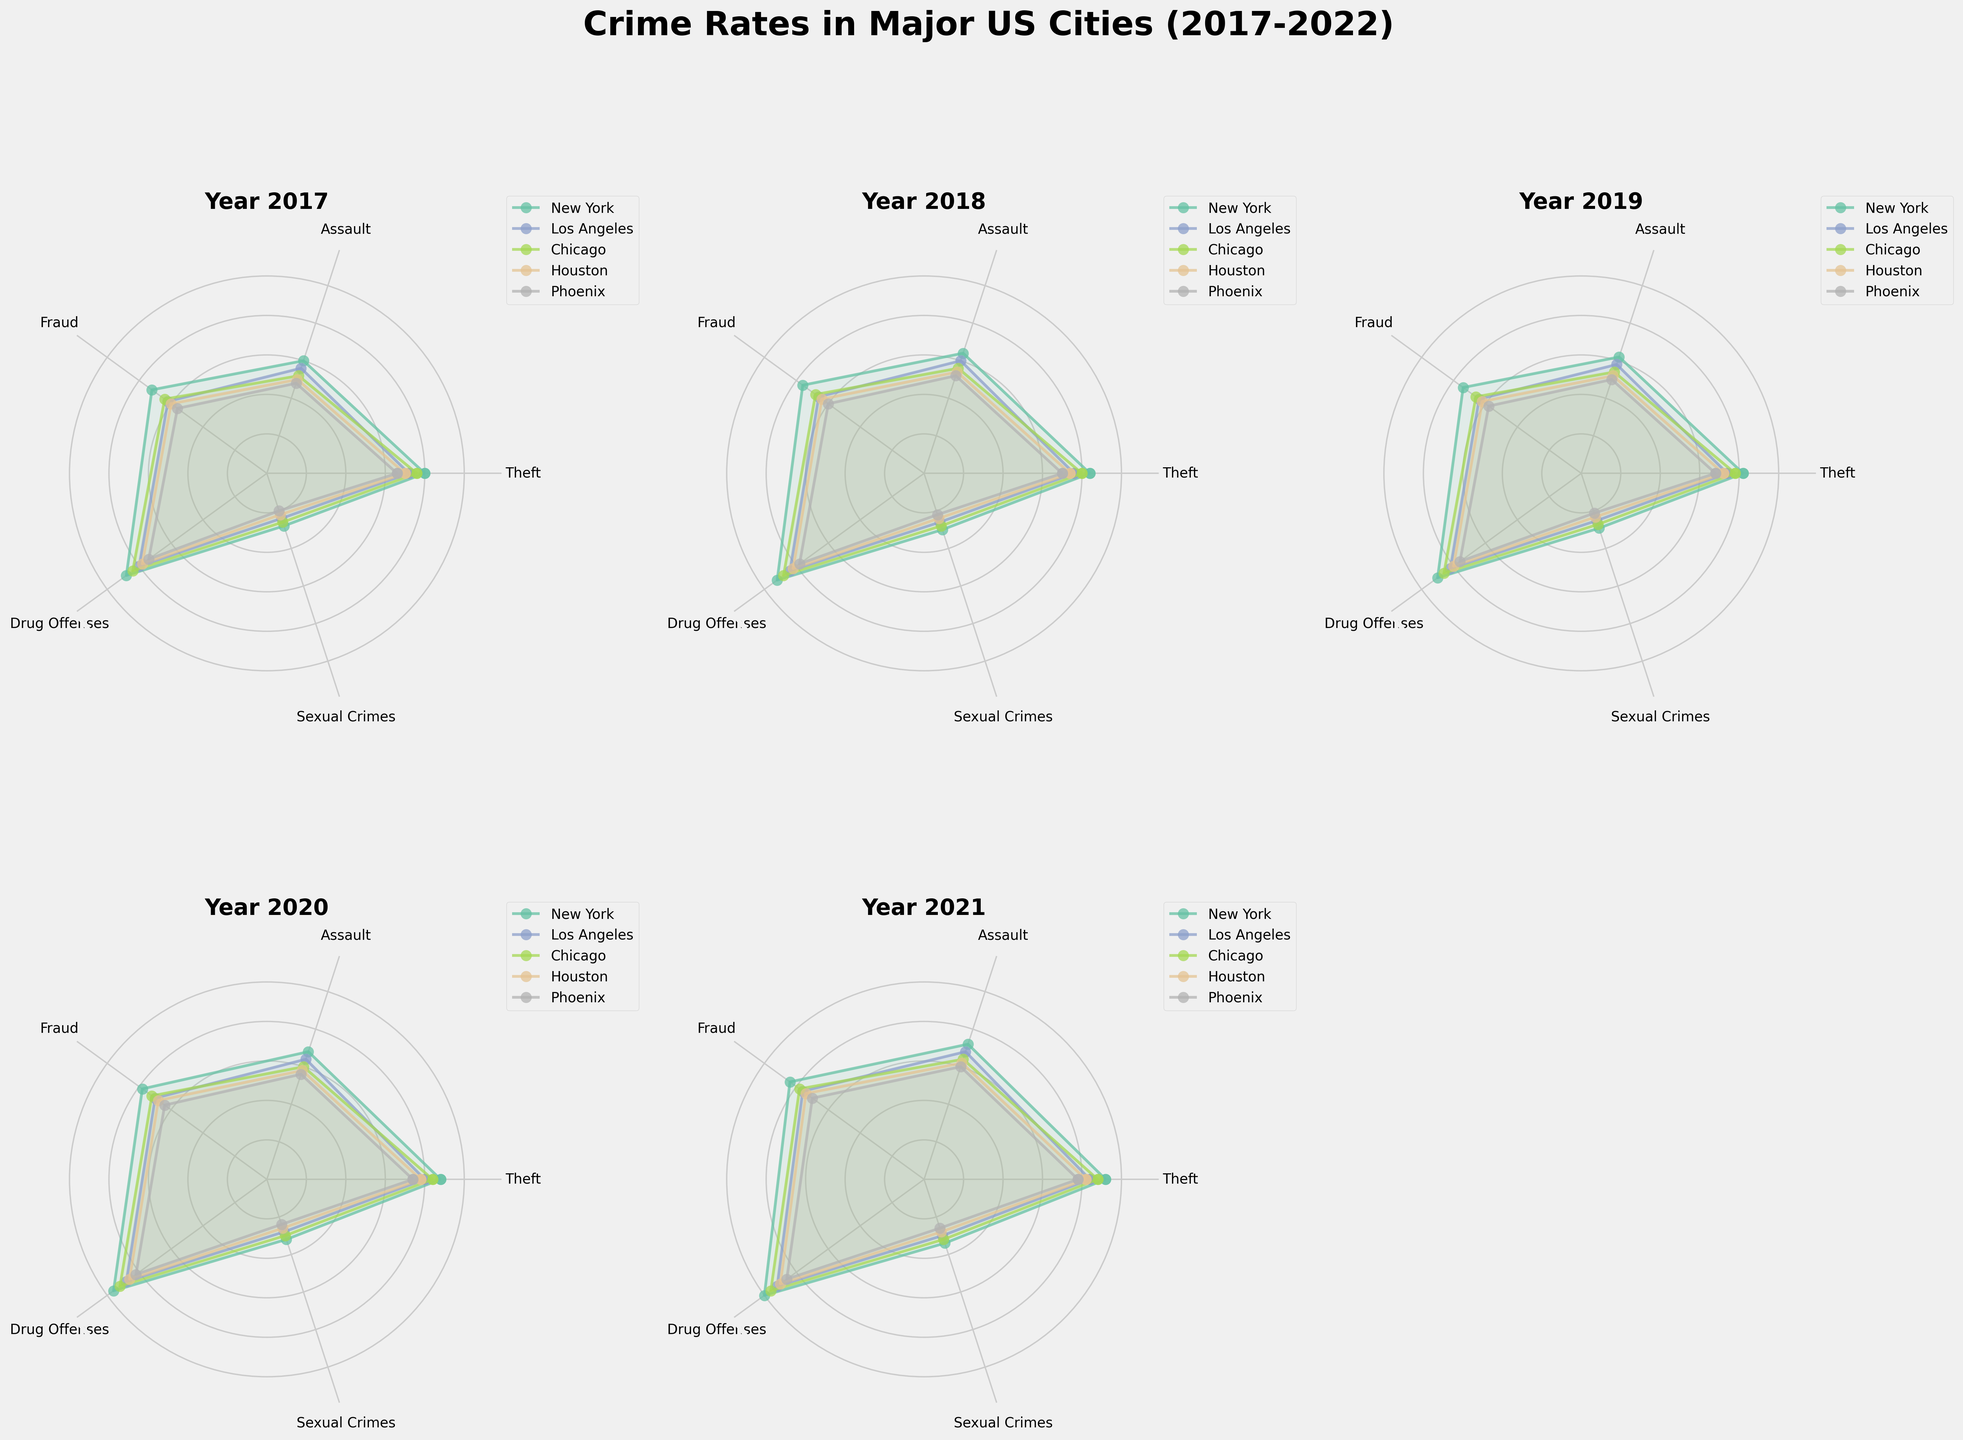How many crime types are displayed in each polar chart? Each polar chart shows a number of crime types as segments around the circle. By counting the segments or the labels, we can determine the number of different crime types displayed.
Answer: 5 What is the overall trend in crime rates from 2017 to 2022 for New York in the category of Theft? First, observe the data points for "Theft" in New York for each year. Spot the pattern of these points. The plot shows an increasing trend for New York's "Theft" from 2017 to 2022.
Answer: Increasing Which city had the lowest number of Drug Offenses in 2019? Locate the segment representing "Drug Offenses" in the chart for the year 2019. Compare the lengths of the data points (which represent crime rates) for different cities. Check which city has the shortest data point in the segment.
Answer: Phoenix What was the average number of Assault cases in Chicago from 2017 to 2022? To find the average, sum the number of Assault cases in Chicago for each year from 2017 to 2022. Divide the result by the number of years (6). Calculate using the values 130, 140, 135, 150, 160, 170. (130 + 140 + 135 + 150 + 160 + 170) / 6 = 785 / 6.
Answer: 130.83 Which city had the highest increase in Fraud cases between 2017 and 2022? To determine the city with the highest increase, look at the Fraud data points for each city in 2017 and 2022. Subtract the 2017 value from the 2022 value for each city. Compare the results to see which city had the highest increase.
Answer: New York For the year 2021, which city reported the highest number of Sexual Crimes? Focus on the segment representing "Sexual Crimes" in the 2021 chart. Identify the data point with the greatest length, which will represent the highest number of Sexual Crimes among the cities.
Answer: New York Compare the trend of Drug Offenses in Houston and Phoenix from 2017 to 2022. Observe the Drug Offenses data points for Houston and Phoenix for each year from 2017 to 2022. Note the pattern: Houston shows a steady increase, while Phoenix has an increasing trend toward the middle years but a slower increase overall.
Answer: Houston: Steady increase, Phoenix: Slower increase Which city had the smallest variation in Theft rates from 2017 to 2022? Calculate the variation by subtracting the minimum value of Theft from the maximum value for each city over the years. The city with the smallest difference has the smallest variation.
Answer: Phoenix How does the overall crime trend for Assault in Los Angeles compare to Chicago from 2017 to 2022? Check the Assault data points for Los Angeles and Chicago each year. In both cities, the trend shows an increase, but Los Angeles has a more pronounced and consistent rise than Chicago.
Answer: Los Angeles: More consistent increase, Chicago: Moderate increase 